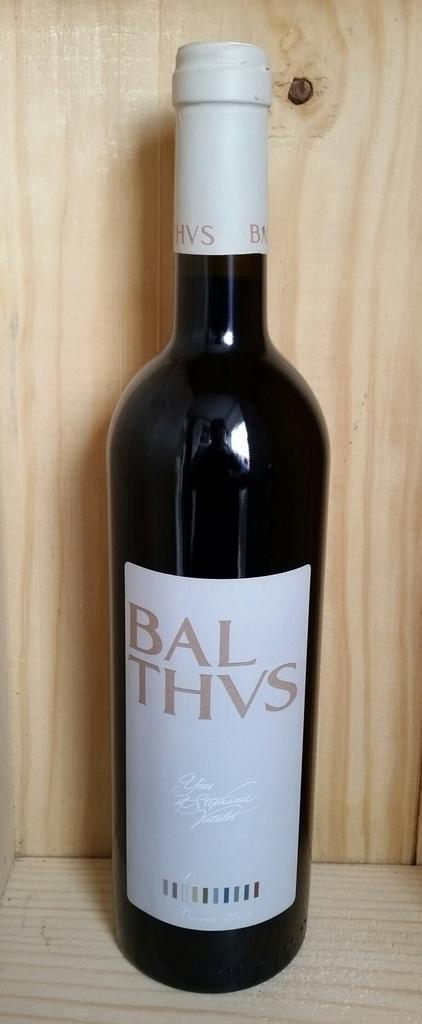<image>
Relay a brief, clear account of the picture shown. A bottle of BAL THVS wine on a wooden shelf. 